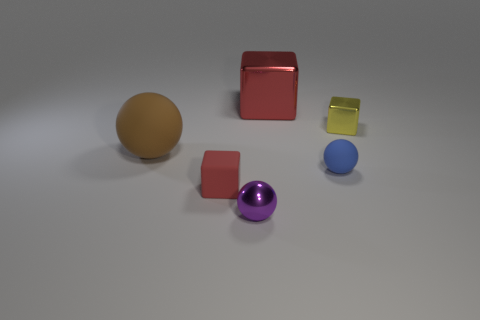Subtract all rubber balls. How many balls are left? 1 Add 1 tiny metal spheres. How many objects exist? 7 Subtract 3 spheres. How many spheres are left? 0 Subtract 0 red balls. How many objects are left? 6 Subtract all brown blocks. Subtract all yellow cylinders. How many blocks are left? 3 Subtract all cyan cubes. How many green balls are left? 0 Subtract all big red cubes. Subtract all large matte things. How many objects are left? 4 Add 4 big red shiny things. How many big red shiny things are left? 5 Add 4 big red shiny objects. How many big red shiny objects exist? 5 Subtract all red cubes. How many cubes are left? 1 